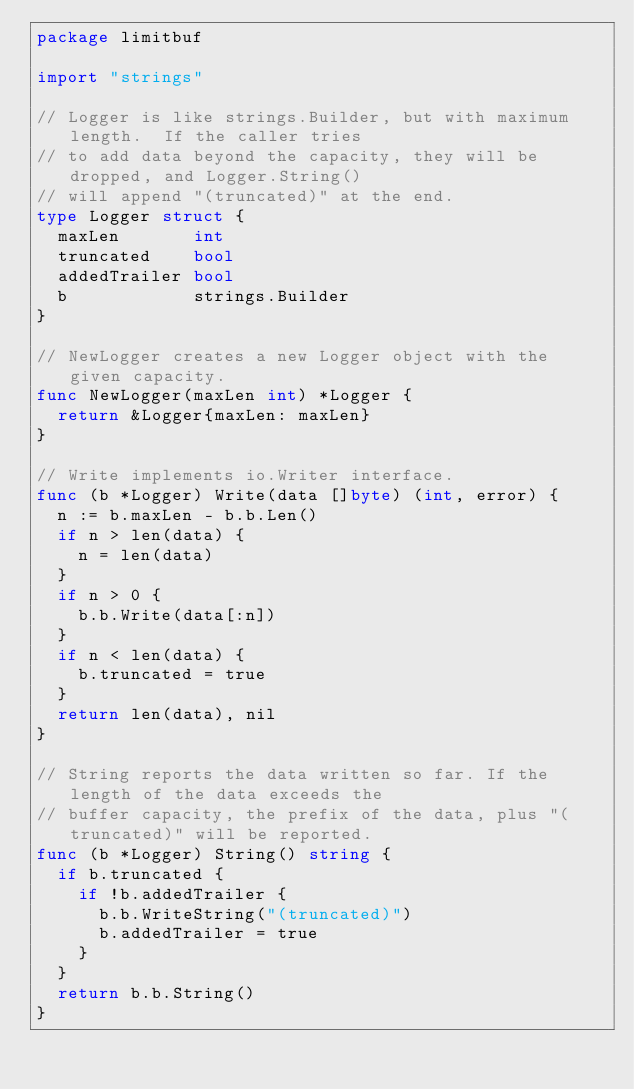<code> <loc_0><loc_0><loc_500><loc_500><_Go_>package limitbuf

import "strings"

// Logger is like strings.Builder, but with maximum length.  If the caller tries
// to add data beyond the capacity, they will be dropped, and Logger.String()
// will append "(truncated)" at the end.
type Logger struct {
	maxLen       int
	truncated    bool
	addedTrailer bool
	b            strings.Builder
}

// NewLogger creates a new Logger object with the given capacity.
func NewLogger(maxLen int) *Logger {
	return &Logger{maxLen: maxLen}
}

// Write implements io.Writer interface.
func (b *Logger) Write(data []byte) (int, error) {
	n := b.maxLen - b.b.Len()
	if n > len(data) {
		n = len(data)
	}
	if n > 0 {
		b.b.Write(data[:n])
	}
	if n < len(data) {
		b.truncated = true
	}
	return len(data), nil
}

// String reports the data written so far. If the length of the data exceeds the
// buffer capacity, the prefix of the data, plus "(truncated)" will be reported.
func (b *Logger) String() string {
	if b.truncated {
		if !b.addedTrailer {
			b.b.WriteString("(truncated)")
			b.addedTrailer = true
		}
	}
	return b.b.String()
}
</code> 